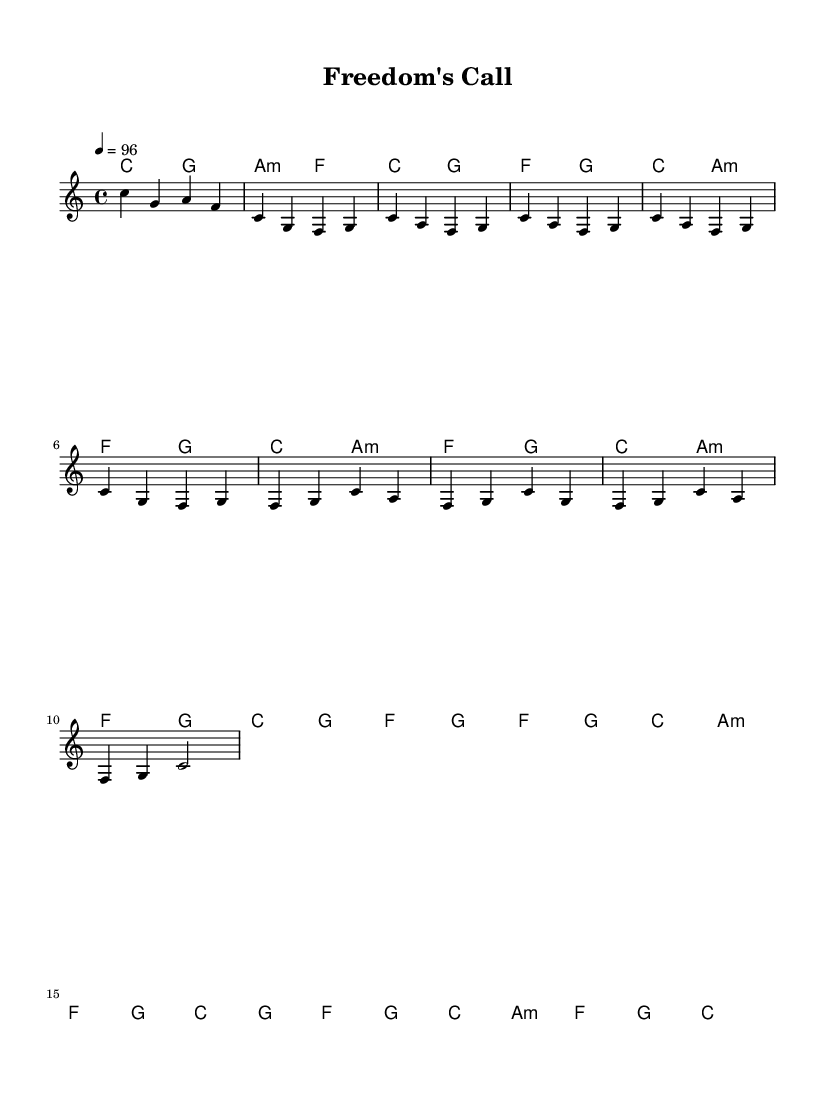What is the key signature of this music? The key signature is indicated in the beginning of the piece with one flat representing C major, which has no sharps or flats.
Answer: C major What is the time signature of this music? The time signature is shown at the beginning and indicates how many beats are in each measure, here it shows 4/4, which means there are four beats per measure.
Answer: 4/4 What is the tempo marking in this music? The tempo marking is present and indicates the speed of the piece; it shows 4 equals 96, meaning there are 96 beats per minute.
Answer: 96 How many measures are in the chorus section? To determine the number of measures in the chorus, I would count the measures in the section labelled as chorus, which consists of 8 measures.
Answer: 8 What type of harmony is used in the introduction? The introduction includes the use of chords, specifically showing the chord progression of C major to G major and A minor to F major.
Answer: Major and minor chords Which style of music does this sheet embody? The sheet music combines elements of reggae and pop, characterized by a laid-back rhythm and catchy melodies indicative of a reggae-pop fusion.
Answer: Reggae-pop fusion 